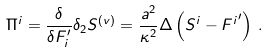<formula> <loc_0><loc_0><loc_500><loc_500>\Pi ^ { i } = \frac { \delta } { \delta F _ { i } ^ { \prime } } \delta _ { 2 } S ^ { ( v ) } = \frac { a ^ { 2 } } { \kappa ^ { 2 } } \Delta \left ( S ^ { i } - { F ^ { i } } ^ { \prime } \right ) \, .</formula> 